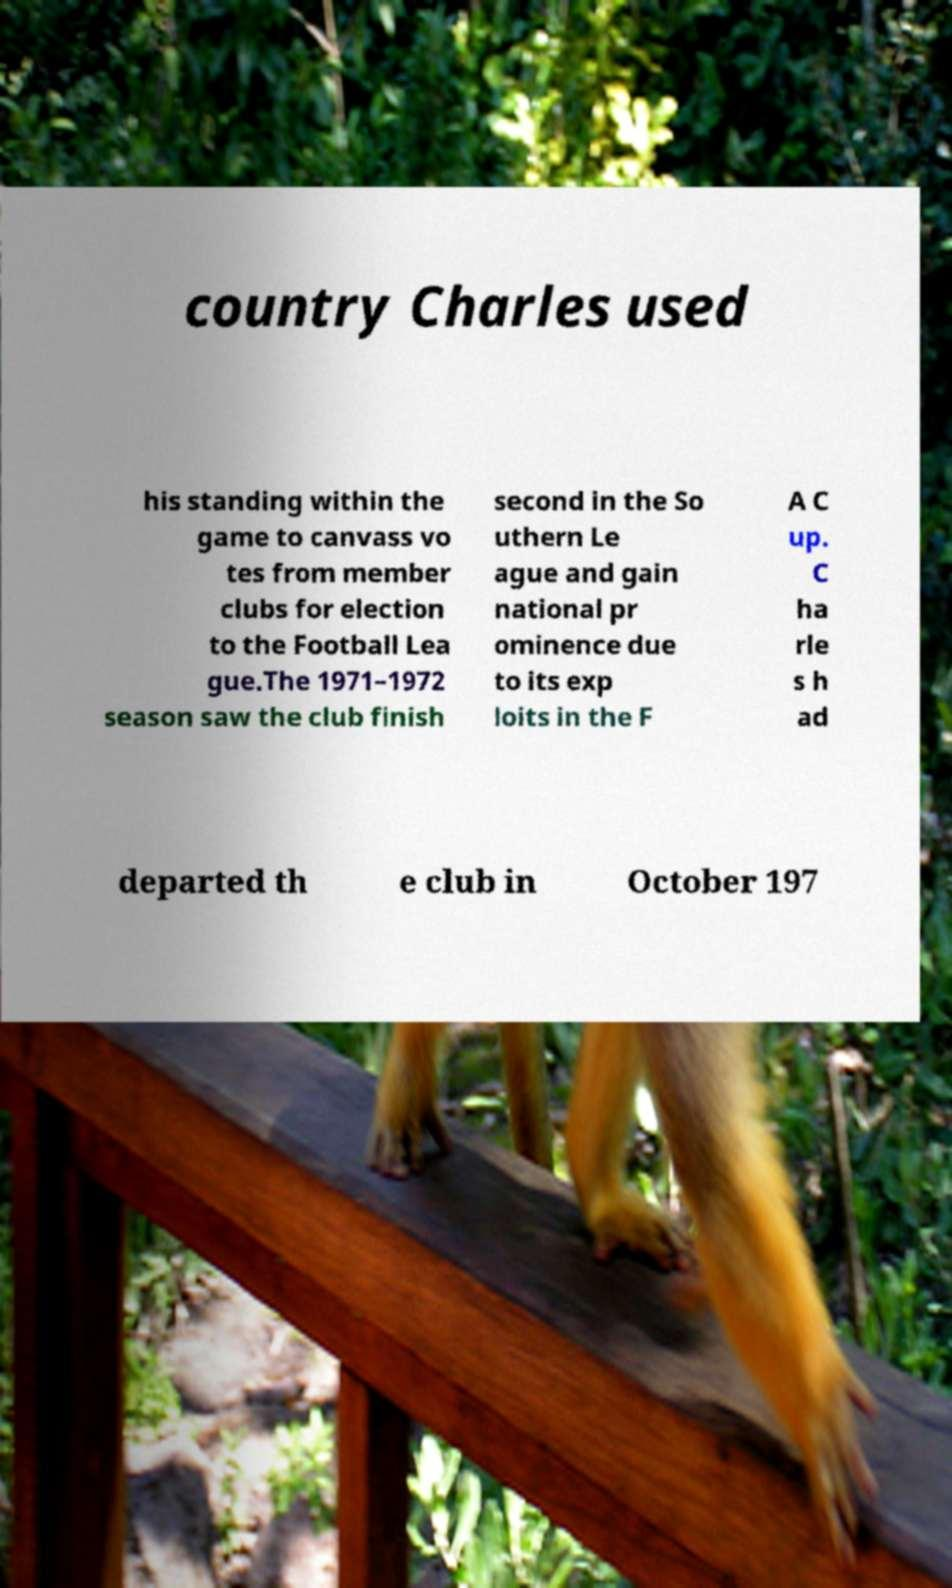Could you assist in decoding the text presented in this image and type it out clearly? country Charles used his standing within the game to canvass vo tes from member clubs for election to the Football Lea gue.The 1971–1972 season saw the club finish second in the So uthern Le ague and gain national pr ominence due to its exp loits in the F A C up. C ha rle s h ad departed th e club in October 197 